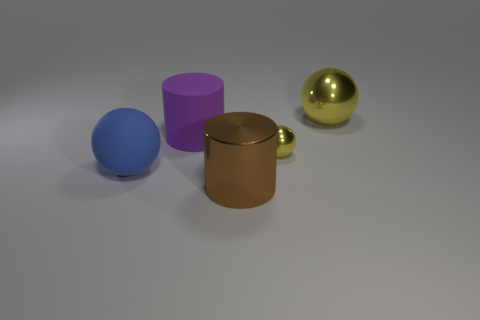Do the cylinder in front of the rubber ball and the large ball to the right of the big blue object have the same color?
Your answer should be compact. No. There is a yellow object that is the same size as the blue matte ball; what is its shape?
Ensure brevity in your answer.  Sphere. What number of objects are either big cylinders that are in front of the large rubber cylinder or big metallic objects that are behind the small object?
Your response must be concise. 2. Are there fewer small purple cylinders than tiny yellow objects?
Your answer should be compact. Yes. What material is the yellow sphere that is the same size as the blue object?
Ensure brevity in your answer.  Metal. Is the size of the cylinder behind the tiny yellow metallic object the same as the blue ball that is left of the big yellow metallic object?
Keep it short and to the point. Yes. Is there a large thing made of the same material as the blue sphere?
Keep it short and to the point. Yes. How many things are large balls to the right of the brown object or big brown cylinders?
Ensure brevity in your answer.  2. Are the yellow object that is to the right of the tiny yellow thing and the small ball made of the same material?
Your answer should be very brief. Yes. Do the big purple rubber thing and the large blue matte thing have the same shape?
Give a very brief answer. No. 